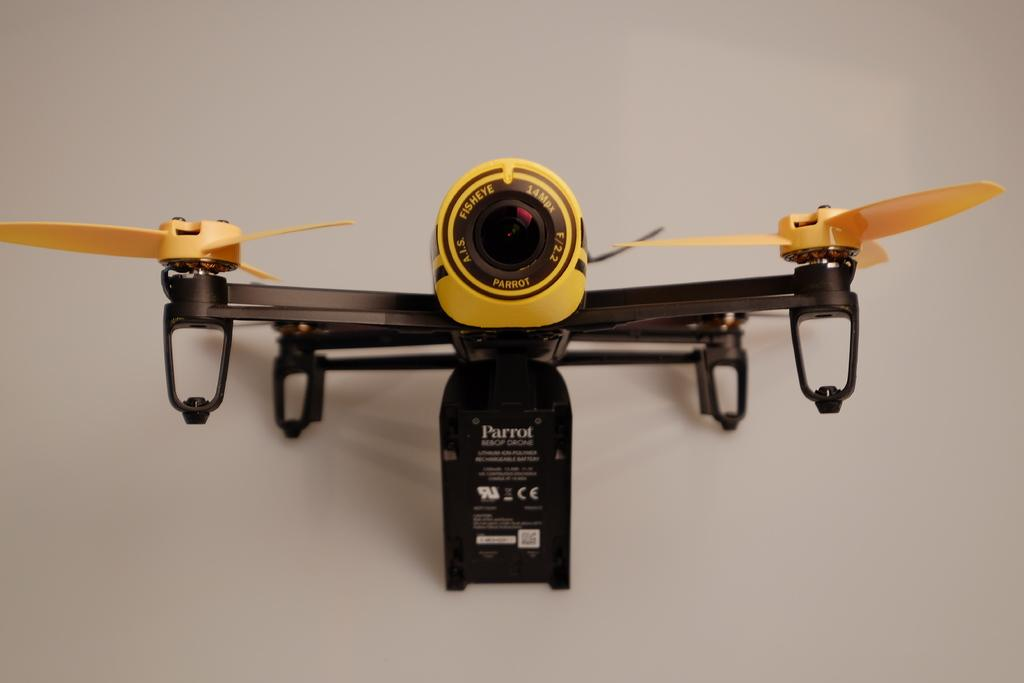What is placed on a surface in the image? There is a toy helicopter placed on a surface in the image. Can you describe the toy helicopter in the image? The toy helicopter is the main subject in the image. What type of hill can be seen in the background of the image? There is no hill present in the image; it features a toy helicopter placed on a surface. 